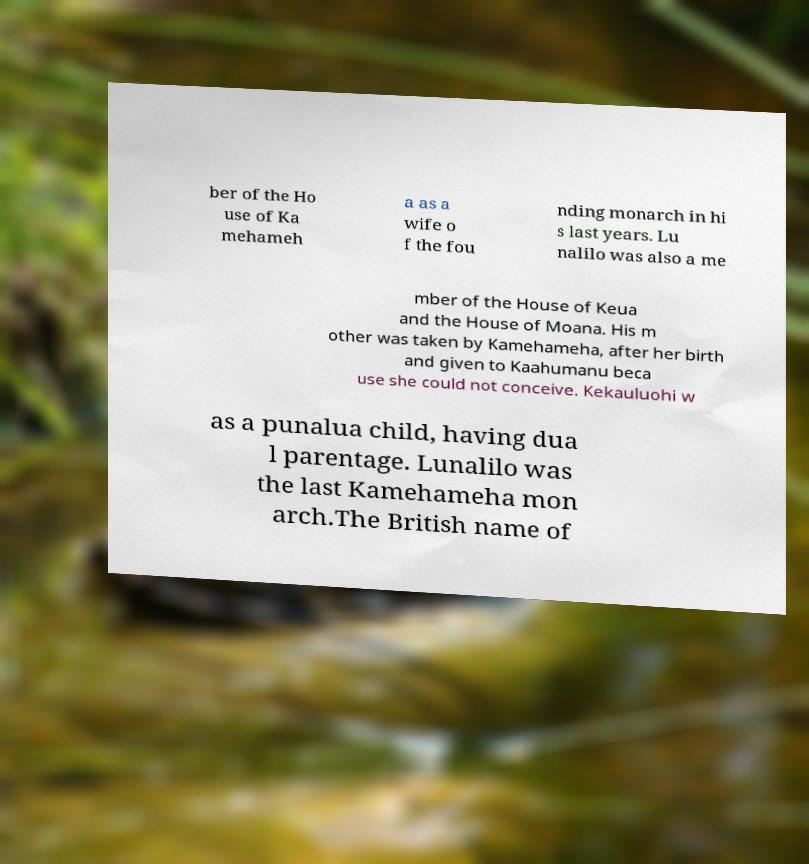Can you accurately transcribe the text from the provided image for me? ber of the Ho use of Ka mehameh a as a wife o f the fou nding monarch in hi s last years. Lu nalilo was also a me mber of the House of Keua and the House of Moana. His m other was taken by Kamehameha, after her birth and given to Kaahumanu beca use she could not conceive. Kekauluohi w as a punalua child, having dua l parentage. Lunalilo was the last Kamehameha mon arch.The British name of 